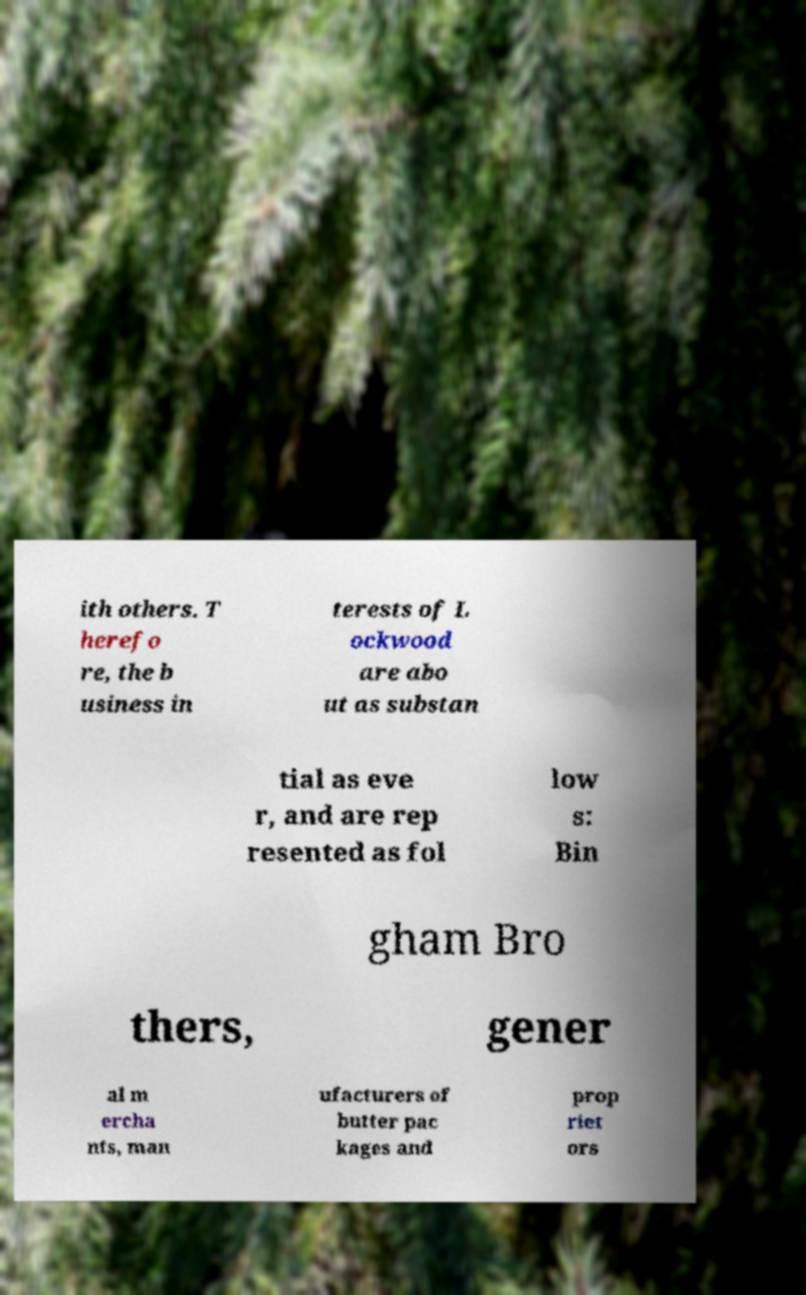Could you extract and type out the text from this image? ith others. T herefo re, the b usiness in terests of L ockwood are abo ut as substan tial as eve r, and are rep resented as fol low s: Bin gham Bro thers, gener al m ercha nts, man ufacturers of butter pac kages and prop riet ors 